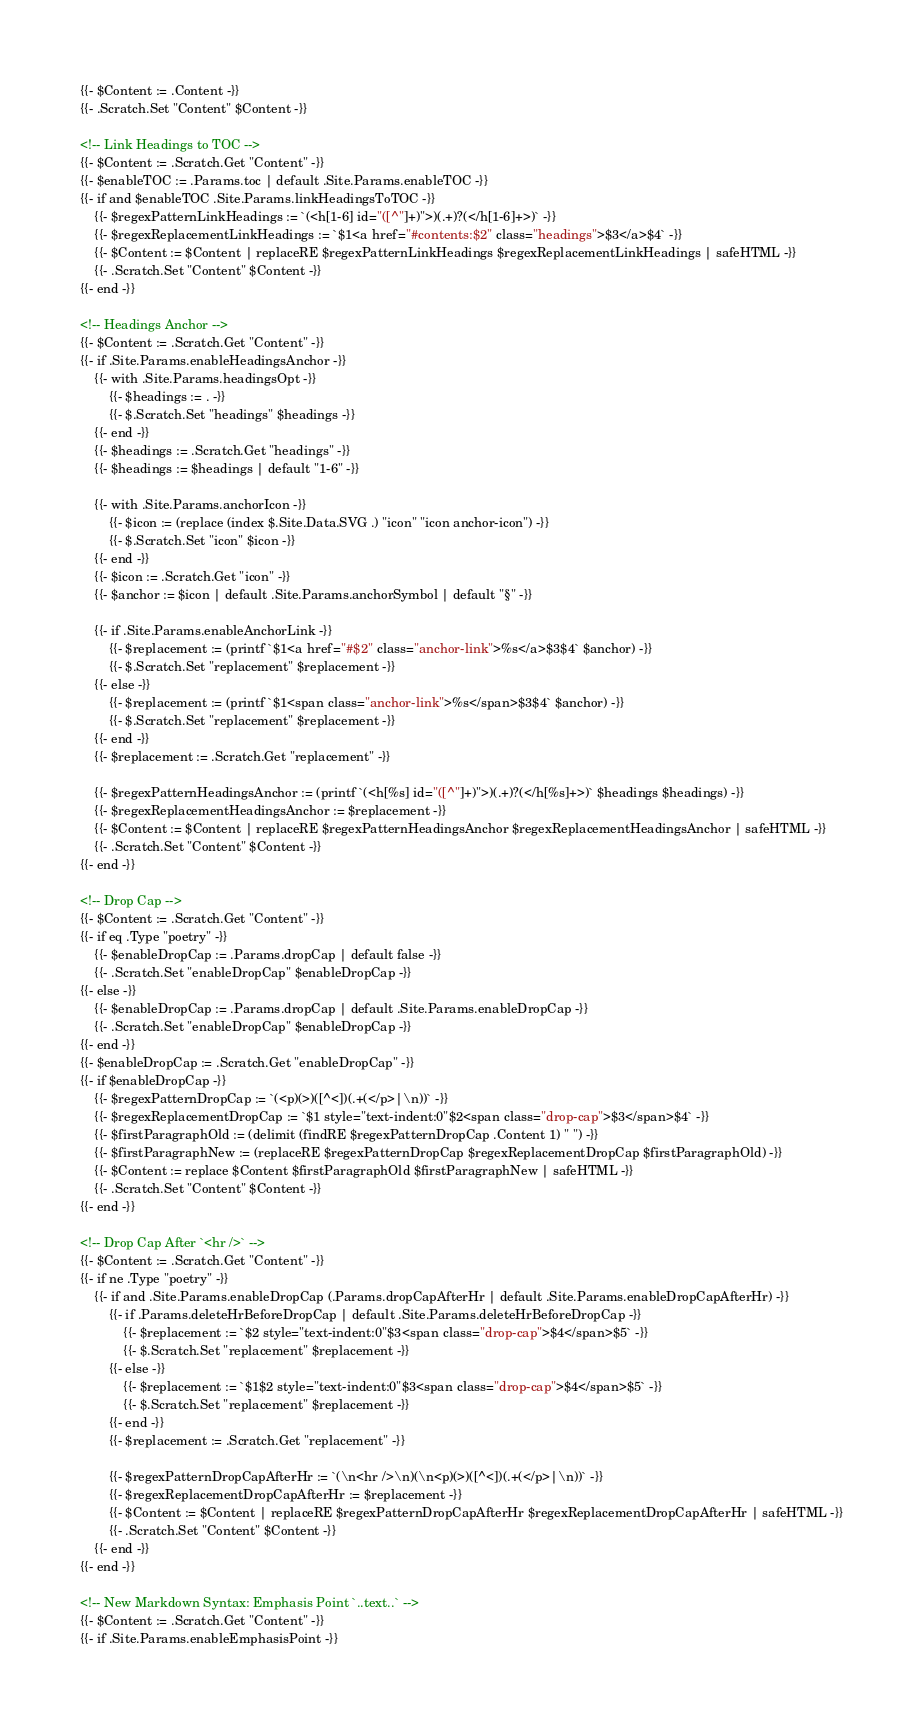Convert code to text. <code><loc_0><loc_0><loc_500><loc_500><_HTML_>{{- $Content := .Content -}}
{{- .Scratch.Set "Content" $Content -}}

<!-- Link Headings to TOC -->
{{- $Content := .Scratch.Get "Content" -}}
{{- $enableTOC := .Params.toc | default .Site.Params.enableTOC -}}
{{- if and $enableTOC .Site.Params.linkHeadingsToTOC -}}
    {{- $regexPatternLinkHeadings := `(<h[1-6] id="([^"]+)">)(.+)?(</h[1-6]+>)` -}}
    {{- $regexReplacementLinkHeadings := `$1<a href="#contents:$2" class="headings">$3</a>$4` -}}
    {{- $Content := $Content | replaceRE $regexPatternLinkHeadings $regexReplacementLinkHeadings | safeHTML -}}
    {{- .Scratch.Set "Content" $Content -}}
{{- end -}}

<!-- Headings Anchor -->
{{- $Content := .Scratch.Get "Content" -}}
{{- if .Site.Params.enableHeadingsAnchor -}}
    {{- with .Site.Params.headingsOpt -}}
        {{- $headings := . -}}
        {{- $.Scratch.Set "headings" $headings -}}
    {{- end -}}
    {{- $headings := .Scratch.Get "headings" -}}
    {{- $headings := $headings | default "1-6" -}}

    {{- with .Site.Params.anchorIcon -}}
        {{- $icon := (replace (index $.Site.Data.SVG .) "icon" "icon anchor-icon") -}}
        {{- $.Scratch.Set "icon" $icon -}}
    {{- end -}}
    {{- $icon := .Scratch.Get "icon" -}}
    {{- $anchor := $icon | default .Site.Params.anchorSymbol | default "§" -}}

    {{- if .Site.Params.enableAnchorLink -}}
        {{- $replacement := (printf `$1<a href="#$2" class="anchor-link">%s</a>$3$4` $anchor) -}}
        {{- $.Scratch.Set "replacement" $replacement -}}
    {{- else -}}
        {{- $replacement := (printf `$1<span class="anchor-link">%s</span>$3$4` $anchor) -}}
        {{- $.Scratch.Set "replacement" $replacement -}}
    {{- end -}}
    {{- $replacement := .Scratch.Get "replacement" -}}

    {{- $regexPatternHeadingsAnchor := (printf `(<h[%s] id="([^"]+)">)(.+)?(</h[%s]+>)` $headings $headings) -}}
    {{- $regexReplacementHeadingsAnchor := $replacement -}}
    {{- $Content := $Content | replaceRE $regexPatternHeadingsAnchor $regexReplacementHeadingsAnchor | safeHTML -}}
    {{- .Scratch.Set "Content" $Content -}}
{{- end -}}

<!-- Drop Cap -->
{{- $Content := .Scratch.Get "Content" -}}
{{- if eq .Type "poetry" -}}
    {{- $enableDropCap := .Params.dropCap | default false -}}
    {{- .Scratch.Set "enableDropCap" $enableDropCap -}}
{{- else -}}
    {{- $enableDropCap := .Params.dropCap | default .Site.Params.enableDropCap -}}
    {{- .Scratch.Set "enableDropCap" $enableDropCap -}}
{{- end -}}
{{- $enableDropCap := .Scratch.Get "enableDropCap" -}}
{{- if $enableDropCap -}}
    {{- $regexPatternDropCap := `(<p)(>)([^<])(.+(</p>|\n))` -}}
    {{- $regexReplacementDropCap := `$1 style="text-indent:0"$2<span class="drop-cap">$3</span>$4` -}}
    {{- $firstParagraphOld := (delimit (findRE $regexPatternDropCap .Content 1) " ") -}}
    {{- $firstParagraphNew := (replaceRE $regexPatternDropCap $regexReplacementDropCap $firstParagraphOld) -}}
    {{- $Content := replace $Content $firstParagraphOld $firstParagraphNew | safeHTML -}}
    {{- .Scratch.Set "Content" $Content -}}
{{- end -}}

<!-- Drop Cap After `<hr />` -->
{{- $Content := .Scratch.Get "Content" -}}
{{- if ne .Type "poetry" -}}
    {{- if and .Site.Params.enableDropCap (.Params.dropCapAfterHr | default .Site.Params.enableDropCapAfterHr) -}}
        {{- if .Params.deleteHrBeforeDropCap | default .Site.Params.deleteHrBeforeDropCap -}}
            {{- $replacement := `$2 style="text-indent:0"$3<span class="drop-cap">$4</span>$5` -}}
            {{- $.Scratch.Set "replacement" $replacement -}}
        {{- else -}}
            {{- $replacement := `$1$2 style="text-indent:0"$3<span class="drop-cap">$4</span>$5` -}}
            {{- $.Scratch.Set "replacement" $replacement -}}
        {{- end -}}
        {{- $replacement := .Scratch.Get "replacement" -}}

        {{- $regexPatternDropCapAfterHr := `(\n<hr />\n)(\n<p)(>)([^<])(.+(</p>|\n))` -}}
        {{- $regexReplacementDropCapAfterHr := $replacement -}}
        {{- $Content := $Content | replaceRE $regexPatternDropCapAfterHr $regexReplacementDropCapAfterHr | safeHTML -}}
        {{- .Scratch.Set "Content" $Content -}}
    {{- end -}}
{{- end -}}

<!-- New Markdown Syntax: Emphasis Point `..text..` -->
{{- $Content := .Scratch.Get "Content" -}}
{{- if .Site.Params.enableEmphasisPoint -}}</code> 